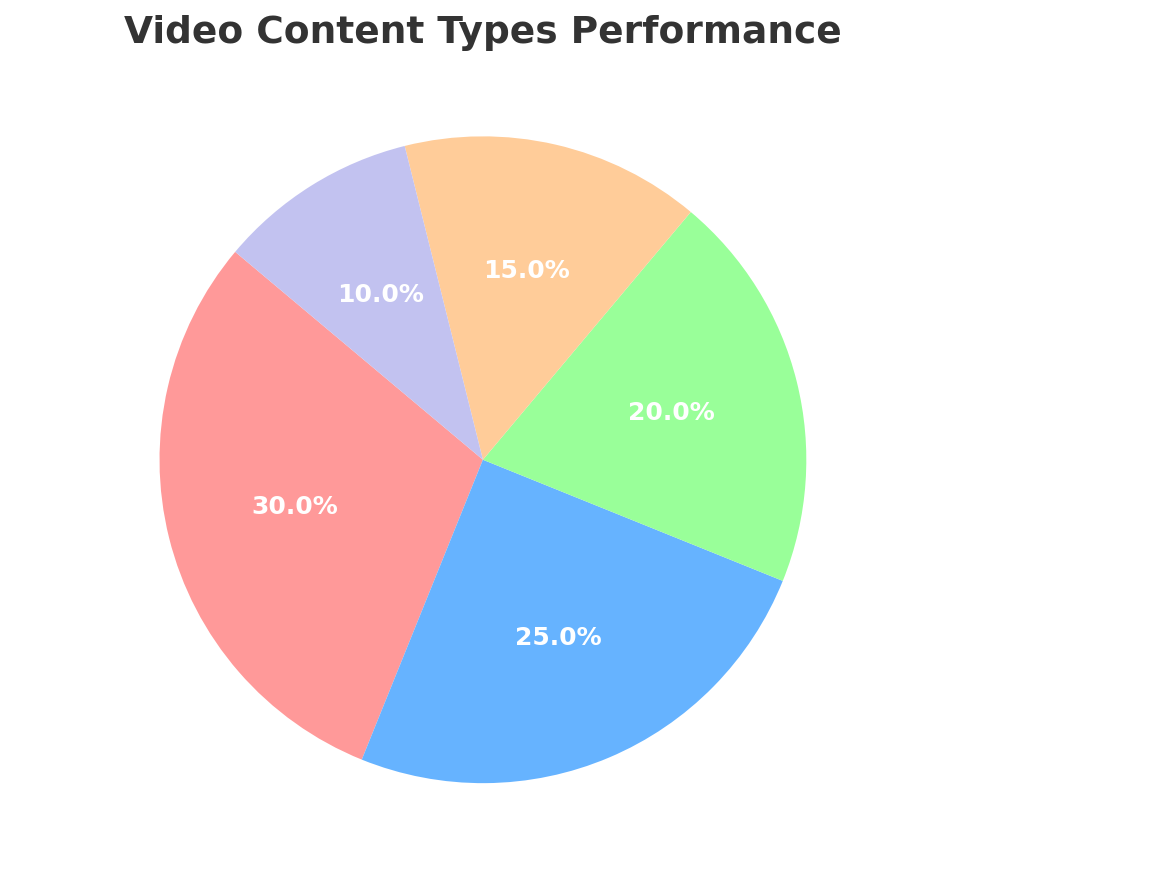What percentage of the pie chart is occupied by 'Tutorials' and 'Product Demos' combined? Add the percentages of 'Tutorials' and 'Product Demos' from the chart: 30% + 25% = 55%
Answer: 55% Which content type has the smallest share in the pie chart? Identify the content type with the smallest percentage in the chart, which is 'Other' at 10%
Answer: Other How much larger is the percentage of 'Tutorials' compared to 'Customer Testimonials'? Subtract the percentage of 'Customer Testimonials' from 'Tutorials': 30% - 20% = 10%
Answer: 10% What is the total percentage of all content types other than 'Product Demos'? Sum the percentages of all content types except 'Product Demos' (30% + 20% + 15% + 10%): 75%
Answer: 75% What is the difference in percentages between the largest and the smallest slices of the pie chart? Subtract the smallest percentage ('Other' at 10%) from the largest percentage ('Tutorials' at 30%): 30% - 10% = 20%
Answer: 20% Which content type is shown with a blue color in the chart? The slice shown with a blue color corresponds to 'Product Demos', as seen in the pie chart.
Answer: Product Demos Are 'Behind-the-Scenes' videos more or less popular than 'Customer Testimonials'? Compare the percentages: 'Behind-the-Scenes' have 15% and 'Customer Testimonials' have 20%. 15% is less than 20%, so 'Behind-the-Scenes' are less popular.
Answer: Less If you were to represent only the top three highest-performing content types in a new pie chart, what would be their combined percentage? Add the percentages of the top three content types: 'Tutorials' (30%), 'Product Demos' (25%), and 'Customer Testimonials' (20%): 30% + 25% + 20% = 75%
Answer: 75% By how much does the percentage of 'Product Demos' exceed the percentage of 'Behind-the-Scenes'? Subtract the percentage of 'Behind-the-Scenes' from 'Product Demos': 25% - 15% = 10%
Answer: 10% If the percentages of 'Behind-the-Scenes' and 'Other' were combined into one category, how would their total percentage compare to 'Tutorials'? Calculate the sum of 'Behind-the-Scenes' and 'Other': 15% + 10% = 25%. Then compare to 'Tutorials': 25% is less than 30%.
Answer: Less 